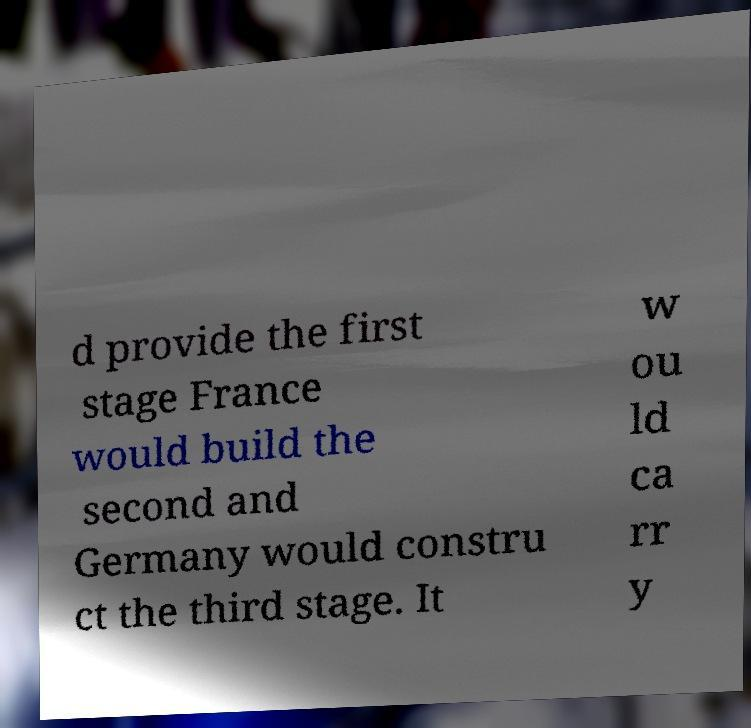For documentation purposes, I need the text within this image transcribed. Could you provide that? d provide the first stage France would build the second and Germany would constru ct the third stage. It w ou ld ca rr y 